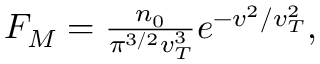<formula> <loc_0><loc_0><loc_500><loc_500>\begin{array} { r } { F _ { M } = \frac { n _ { 0 } } { \pi ^ { 3 / 2 } v _ { T } ^ { 3 } } e ^ { - v ^ { 2 } / v _ { T } ^ { 2 } } , } \end{array}</formula> 